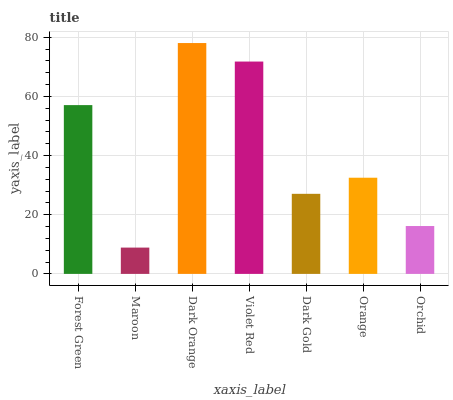Is Maroon the minimum?
Answer yes or no. Yes. Is Dark Orange the maximum?
Answer yes or no. Yes. Is Dark Orange the minimum?
Answer yes or no. No. Is Maroon the maximum?
Answer yes or no. No. Is Dark Orange greater than Maroon?
Answer yes or no. Yes. Is Maroon less than Dark Orange?
Answer yes or no. Yes. Is Maroon greater than Dark Orange?
Answer yes or no. No. Is Dark Orange less than Maroon?
Answer yes or no. No. Is Orange the high median?
Answer yes or no. Yes. Is Orange the low median?
Answer yes or no. Yes. Is Dark Gold the high median?
Answer yes or no. No. Is Forest Green the low median?
Answer yes or no. No. 